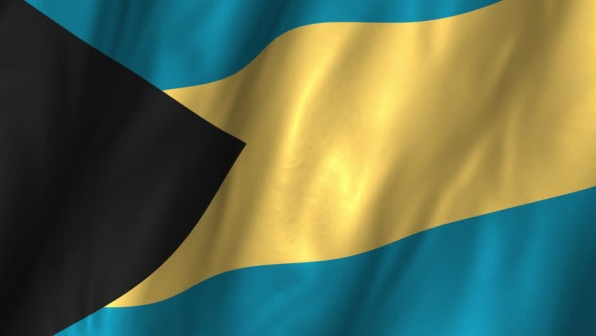The flag transforms into a magical gateway. Where does it lead, and what adventures await there? The flag ripples and opens as a magical portal, leading to an enchanting realm beneath the aquamarine waters surrounding the Bahamas. Entering through the gateway, one finds themselves in an underwater paradise, where vibrant coral reefs teem with exotic marine life. Schools of iridescent fish swim by, and playful dolphins dive and leap in the distance. Amidst the underwater splendor, a hidden city emerges, crafted entirely from seashells and sea glass, governed by a wise council of mystical sea creatures. Adventures await in the quest to find ancient treasures buried in sunken ships and to unlock the secrets of the ocean's depths, all while protecting this magical world from those who threaten its delicate beauty. 